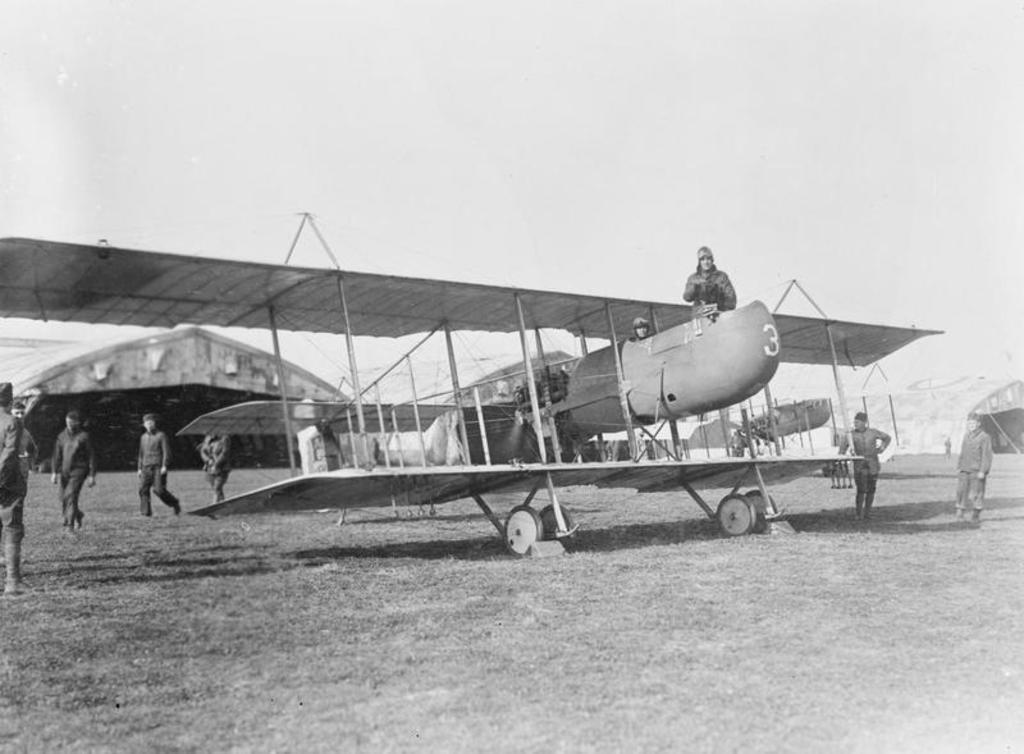What is the main subject of the image? The main subject of the image is an aircraft. What can be seen on the ground in the image? There are persons on the ground in the image. Are there any people inside the aircraft? Yes, there are persons inside the aircraft. What can be seen in the background of the image? There are tents in the background of the image. What type of scent can be detected coming from the aircraft in the image? There is no information about any scent in the image, so it cannot be determined. 